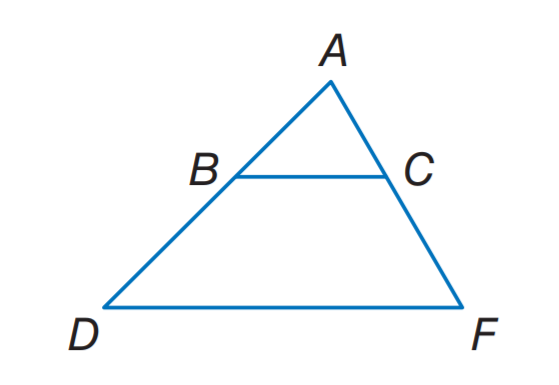Can you determine the area of triangle ABD in the image if AB = x + 5 and BD = 12? Given AB = x + 5 and BD = 12, we first need to use the value of x that we previously calculated. Assuming we have that value, let's say it is 'k.' Area of a triangle is 1/2 * base * height. Since ABD is an isosceles triangle, height would drop from A to the midpoint of BD, we can calculate the height using Pythagorean theorem if we know AD (which is half of BD) and AB. Once we determine the height, we can calculate the area of triangle ABD. 